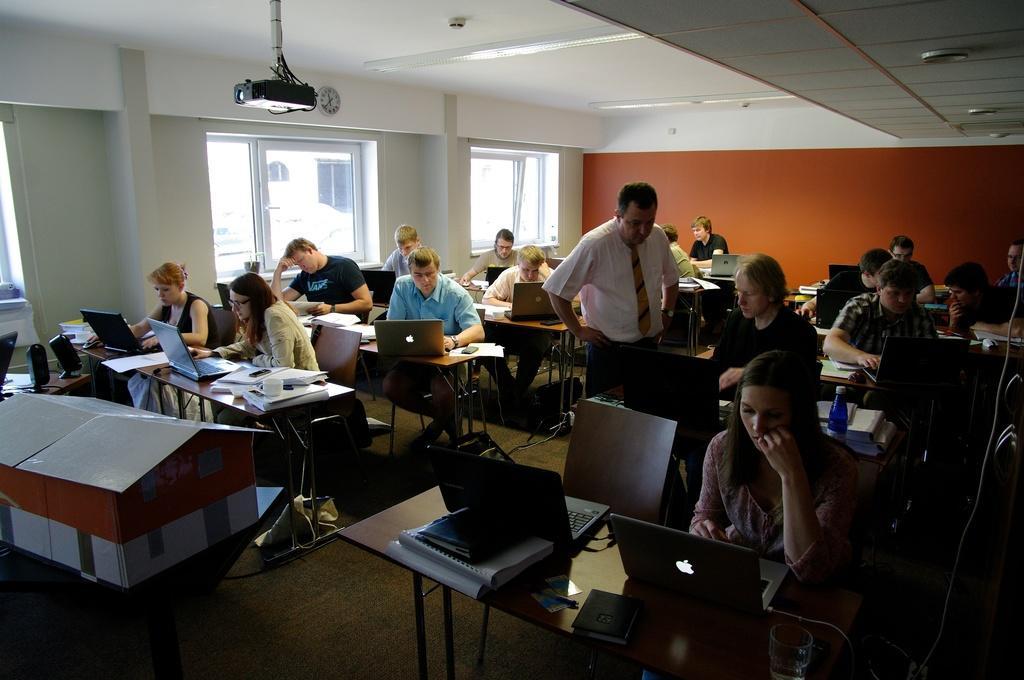How would you summarize this image in a sentence or two? In this image we can see a group of persons. In front of the persons we can see few objects on the tables. Behind the persons we can see the wall and windows. At the top we can see the roof, lights and a projector. On the left side, we can see few objects on the tables. 